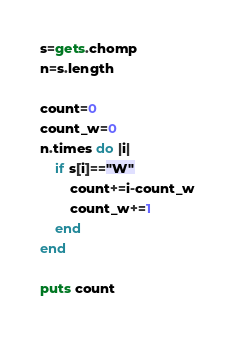Convert code to text. <code><loc_0><loc_0><loc_500><loc_500><_Ruby_>s=gets.chomp
n=s.length

count=0
count_w=0
n.times do |i|
    if s[i]=="W"
        count+=i-count_w
        count_w+=1
    end
end

puts count
</code> 